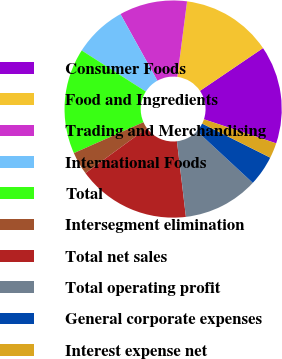Convert chart. <chart><loc_0><loc_0><loc_500><loc_500><pie_chart><fcel>Consumer Foods<fcel>Food and Ingredients<fcel>Trading and Merchandising<fcel>International Foods<fcel>Total<fcel>Intersegment elimination<fcel>Total net sales<fcel>Total operating profit<fcel>General corporate expenses<fcel>Interest expense net<nl><fcel>14.6%<fcel>13.47%<fcel>10.11%<fcel>7.87%<fcel>15.72%<fcel>3.39%<fcel>16.84%<fcel>11.23%<fcel>4.51%<fcel>2.27%<nl></chart> 